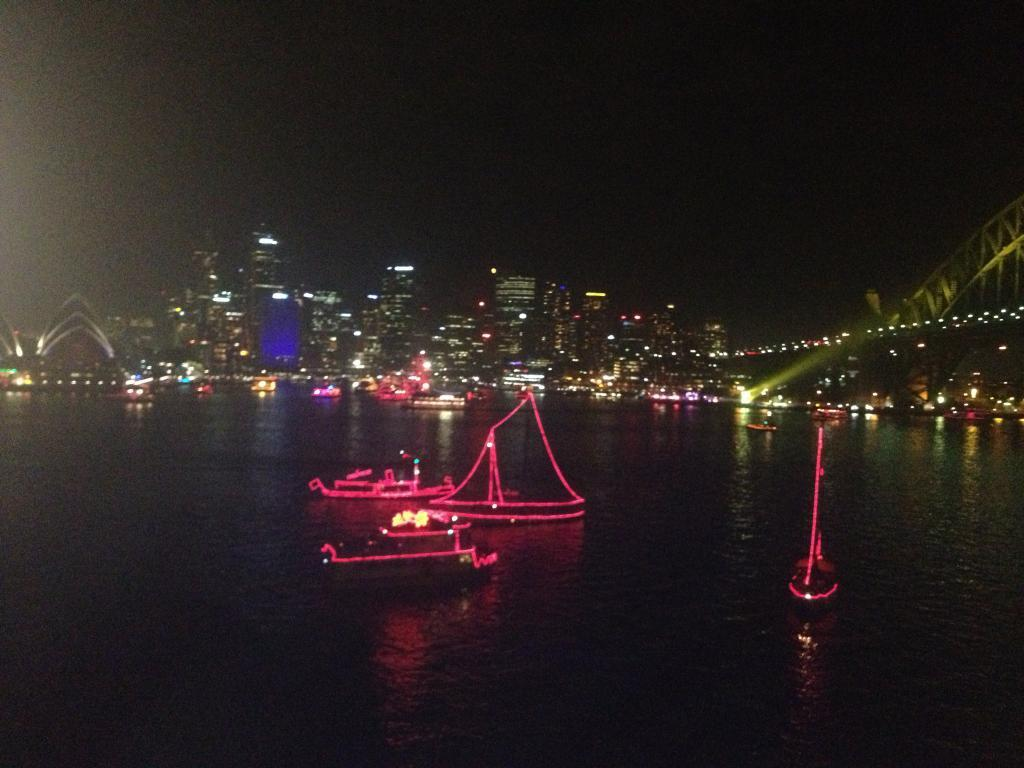What type of vehicles are in the image? There are boats with lights in the image. Where are the boats located? The boats are on the water. What else can be seen in the image besides the boats? There are buildings visible in the image. How would you describe the overall appearance of the image? The image has a dark background. What type of story is being told by the boats in the image? There is no story being told by the boats in the image; they are simply boats with lights on the water. Can you identify any spies in the image? There are no spies present in the image. 